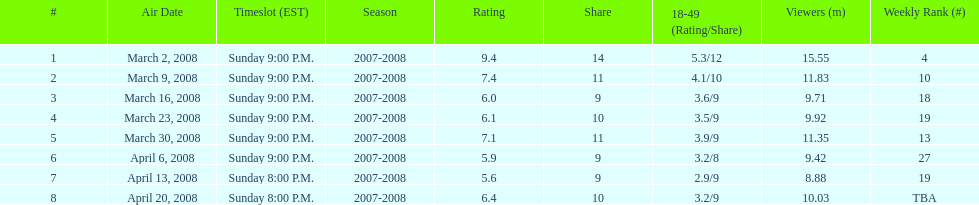How long did the program air for in days? 8. Would you be able to parse every entry in this table? {'header': ['#', 'Air Date', 'Timeslot (EST)', 'Season', 'Rating', 'Share', '18-49 (Rating/Share)', 'Viewers (m)', 'Weekly Rank (#)'], 'rows': [['1', 'March 2, 2008', 'Sunday 9:00 P.M.', '2007-2008', '9.4', '14', '5.3/12', '15.55', '4'], ['2', 'March 9, 2008', 'Sunday 9:00 P.M.', '2007-2008', '7.4', '11', '4.1/10', '11.83', '10'], ['3', 'March 16, 2008', 'Sunday 9:00 P.M.', '2007-2008', '6.0', '9', '3.6/9', '9.71', '18'], ['4', 'March 23, 2008', 'Sunday 9:00 P.M.', '2007-2008', '6.1', '10', '3.5/9', '9.92', '19'], ['5', 'March 30, 2008', 'Sunday 9:00 P.M.', '2007-2008', '7.1', '11', '3.9/9', '11.35', '13'], ['6', 'April 6, 2008', 'Sunday 9:00 P.M.', '2007-2008', '5.9', '9', '3.2/8', '9.42', '27'], ['7', 'April 13, 2008', 'Sunday 8:00 P.M.', '2007-2008', '5.6', '9', '2.9/9', '8.88', '19'], ['8', 'April 20, 2008', 'Sunday 8:00 P.M.', '2007-2008', '6.4', '10', '3.2/9', '10.03', 'TBA']]} 